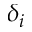Convert formula to latex. <formula><loc_0><loc_0><loc_500><loc_500>\delta _ { i }</formula> 